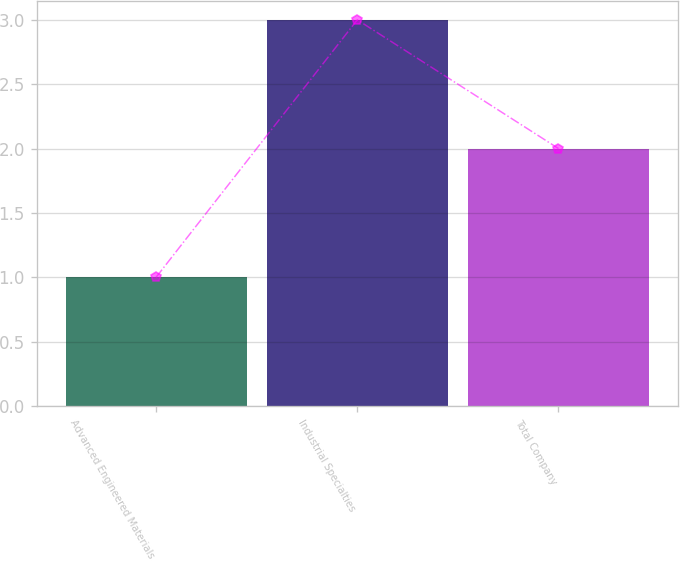Convert chart. <chart><loc_0><loc_0><loc_500><loc_500><bar_chart><fcel>Advanced Engineered Materials<fcel>Industrial Specialties<fcel>Total Company<nl><fcel>1<fcel>3<fcel>2<nl></chart> 